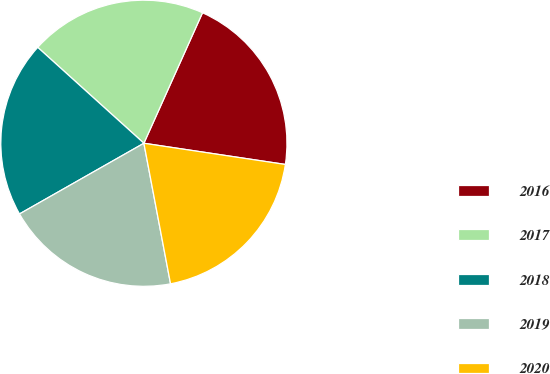Convert chart to OTSL. <chart><loc_0><loc_0><loc_500><loc_500><pie_chart><fcel>2016<fcel>2017<fcel>2018<fcel>2019<fcel>2020<nl><fcel>20.65%<fcel>20.03%<fcel>19.92%<fcel>19.76%<fcel>19.65%<nl></chart> 